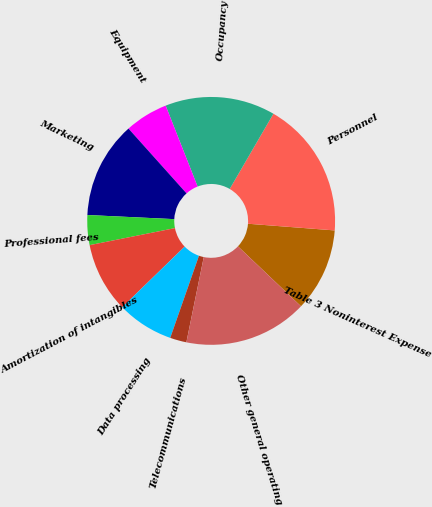<chart> <loc_0><loc_0><loc_500><loc_500><pie_chart><fcel>Table 3 Noninterest Expense<fcel>Personnel<fcel>Occupancy<fcel>Equipment<fcel>Marketing<fcel>Professional fees<fcel>Amortization of intangibles<fcel>Data processing<fcel>Telecommunications<fcel>Other general operating<nl><fcel>10.87%<fcel>17.85%<fcel>14.36%<fcel>5.64%<fcel>12.62%<fcel>3.89%<fcel>9.13%<fcel>7.38%<fcel>2.15%<fcel>16.11%<nl></chart> 